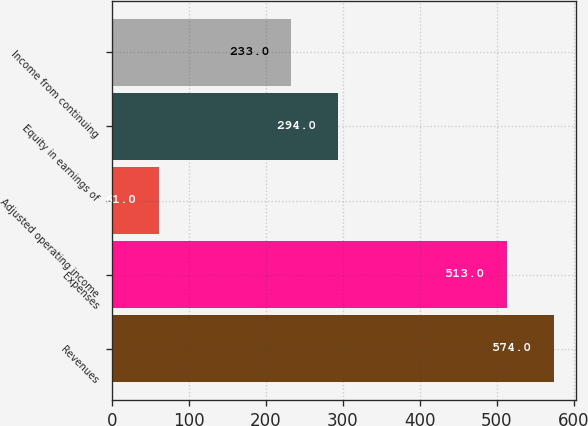<chart> <loc_0><loc_0><loc_500><loc_500><bar_chart><fcel>Revenues<fcel>Expenses<fcel>Adjusted operating income<fcel>Equity in earnings of<fcel>Income from continuing<nl><fcel>574<fcel>513<fcel>61<fcel>294<fcel>233<nl></chart> 